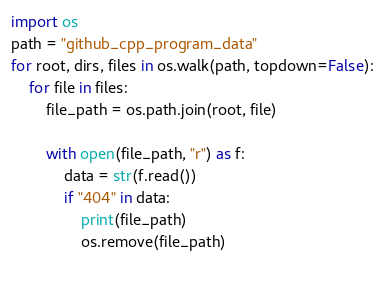<code> <loc_0><loc_0><loc_500><loc_500><_Python_>import os
path = "github_cpp_program_data"
for root, dirs, files in os.walk(path, topdown=False):
	for file in files:
		file_path = os.path.join(root, file)

		with open(file_path, "r") as f:
			data = str(f.read())
			if "404" in data:
				print(file_path)
				os.remove(file_path)
  </code> 